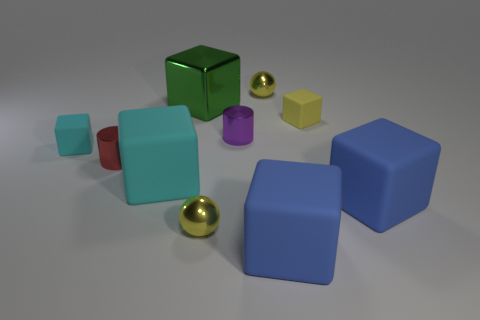Subtract all yellow blocks. How many blocks are left? 5 Subtract all small blocks. How many blocks are left? 4 Subtract 3 blocks. How many blocks are left? 3 Subtract all yellow cubes. Subtract all brown balls. How many cubes are left? 5 Subtract all balls. How many objects are left? 8 Add 8 small purple metal things. How many small purple metal things are left? 9 Add 3 metallic things. How many metallic things exist? 8 Subtract 0 green spheres. How many objects are left? 10 Subtract all yellow metallic balls. Subtract all big green objects. How many objects are left? 7 